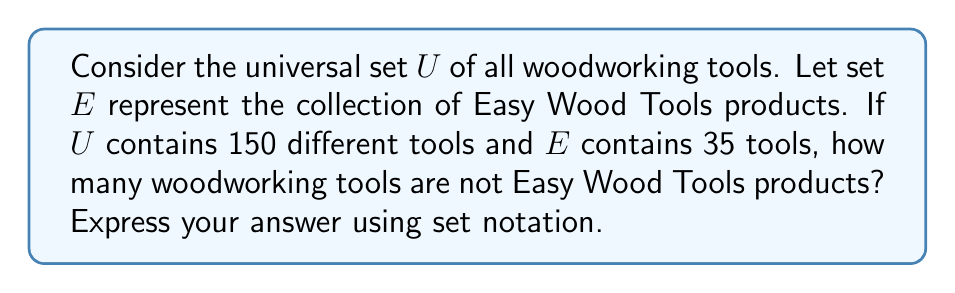Could you help me with this problem? To solve this problem, we need to use the concept of set complement. The complement of a set $A$ within a universal set $U$ is denoted as $A^c$ or $U \setminus A$, and it contains all elements in $U$ that are not in $A$.

Given:
- $U$ is the universal set of all woodworking tools
- $E$ is the set of Easy Wood Tools products
- $|U| = 150$ (cardinality of $U$)
- $|E| = 35$ (cardinality of $E$)

We want to find $|E^c|$, which is the number of woodworking tools that are not Easy Wood Tools products.

Using the relationship between a set and its complement:

$$|U| = |E| + |E^c|$$

We can rearrange this equation to solve for $|E^c|$:

$$|E^c| = |U| - |E|$$

Substituting the given values:

$$|E^c| = 150 - 35 = 115$$

Therefore, there are 115 woodworking tools that are not Easy Wood Tools products.

In set notation, we can express this as:

$$|U \setminus E| = 115$$
Answer: $|U \setminus E| = 115$ 